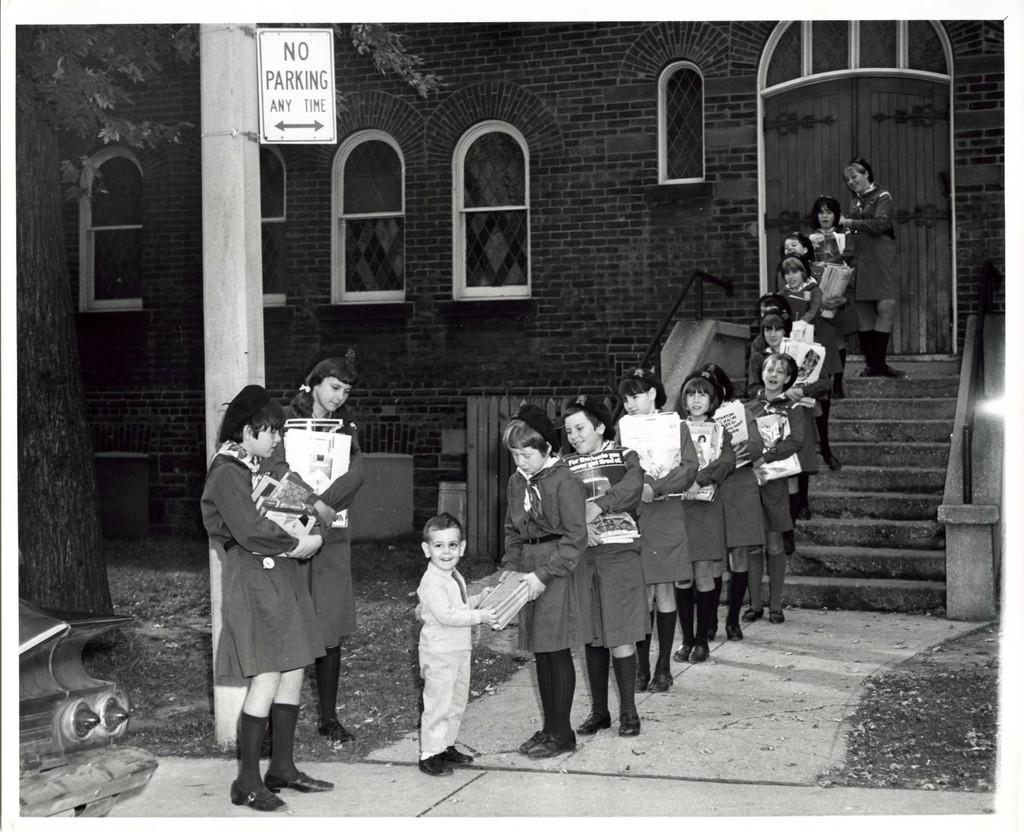Describe this image in one or two sentences. This is a black and white image. On the left there are two girls holding books in their hands and in front of them a kid is distributing books to a girl and behind her there are few more girls in queue. In the background there is a building,doors,windows and a tree on the left side. 